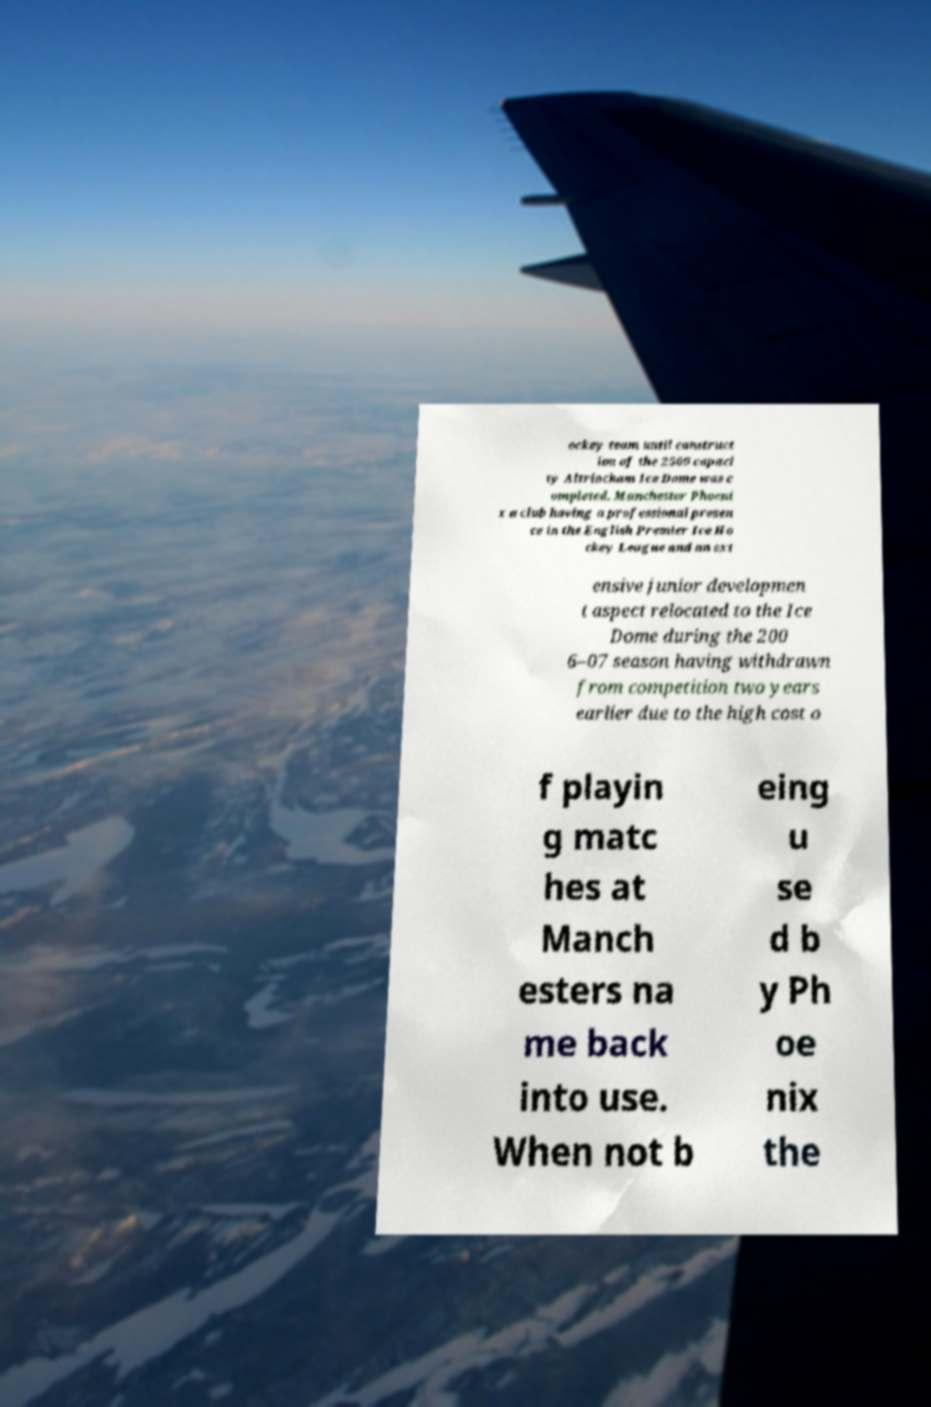There's text embedded in this image that I need extracted. Can you transcribe it verbatim? ockey team until construct ion of the 2500 capaci ty Altrincham Ice Dome was c ompleted. Manchester Phoeni x a club having a professional presen ce in the English Premier Ice Ho ckey League and an ext ensive junior developmen t aspect relocated to the Ice Dome during the 200 6–07 season having withdrawn from competition two years earlier due to the high cost o f playin g matc hes at Manch esters na me back into use. When not b eing u se d b y Ph oe nix the 